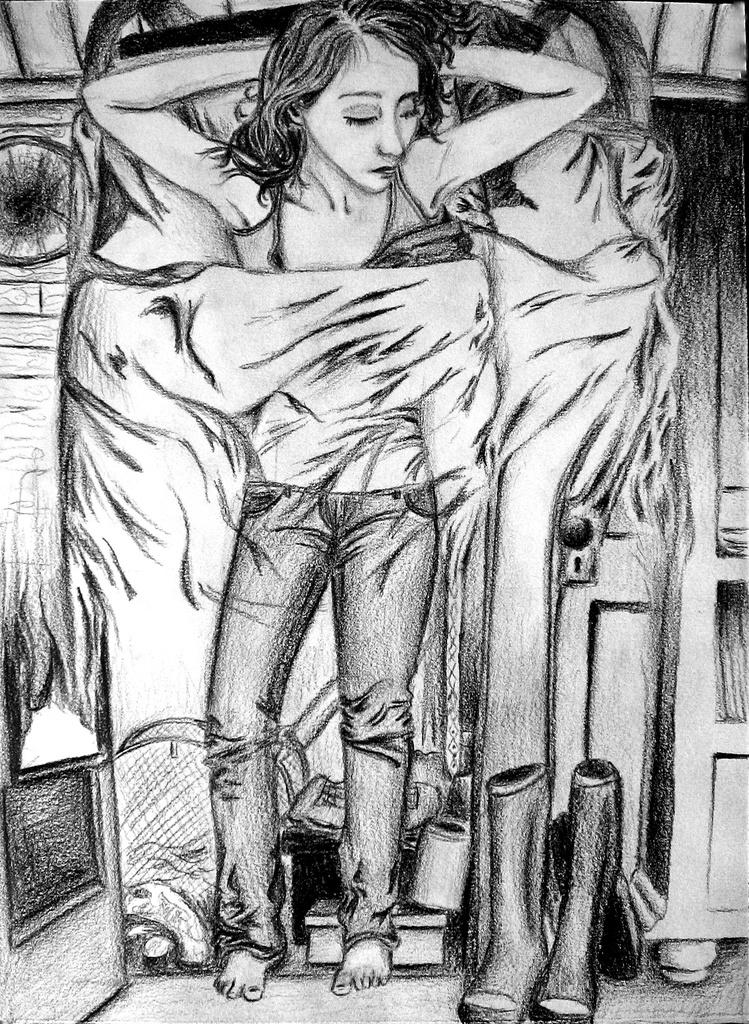What is the main subject of the image? The image contains a sketch. What is happening in the sketch? There is a person sleeping on the bed in the sketch. What type of footwear is visible in the sketch? There are boots visible in the sketch. Are there any other objects present in the sketch besides the person and boots? Yes, there are other objects present in the sketch. What news is the turkey reading in the image? There is no turkey or news present in the image; it contains a sketch of a person sleeping on a bed with boots and other objects. 